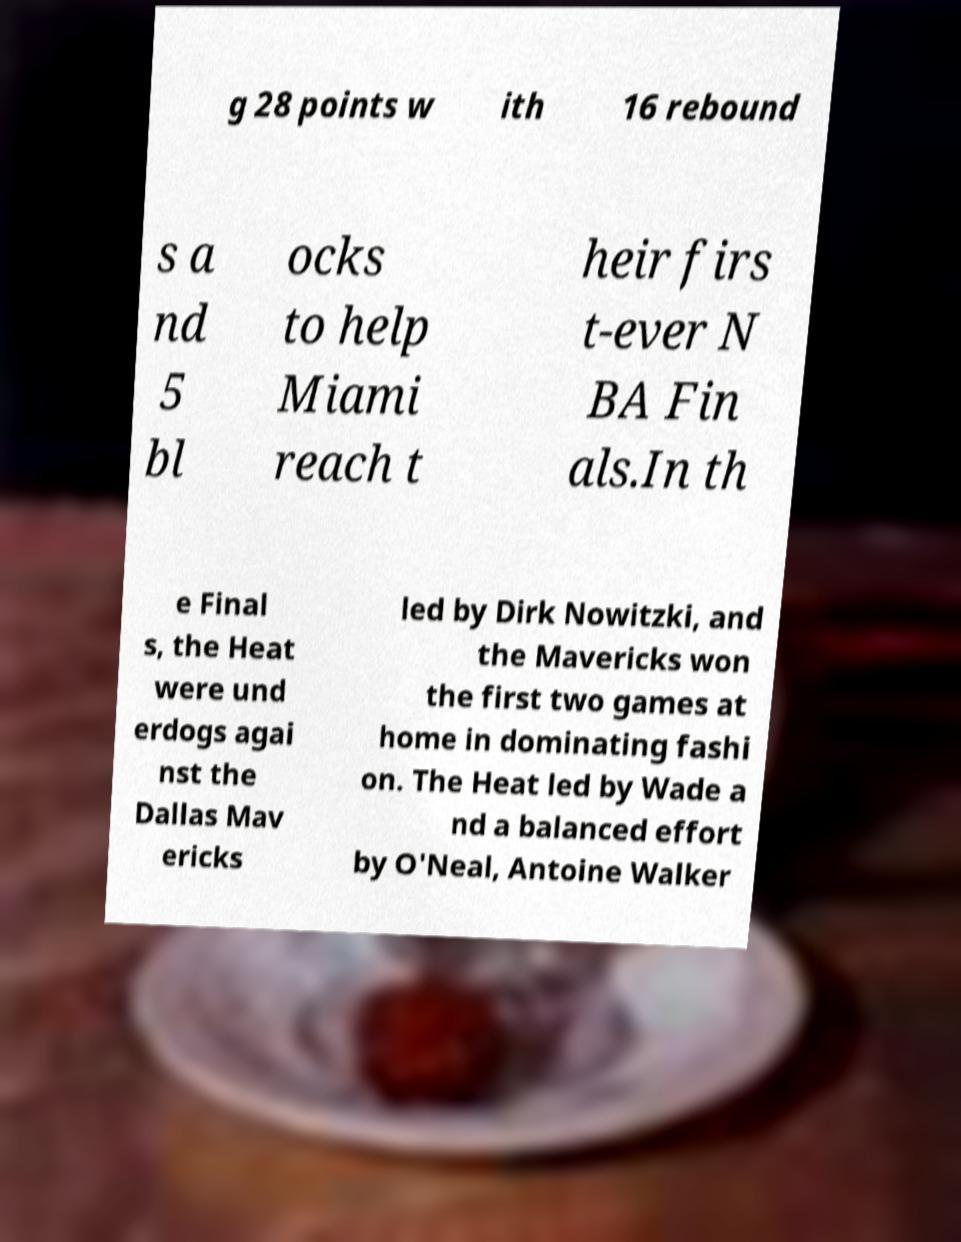I need the written content from this picture converted into text. Can you do that? g 28 points w ith 16 rebound s a nd 5 bl ocks to help Miami reach t heir firs t-ever N BA Fin als.In th e Final s, the Heat were und erdogs agai nst the Dallas Mav ericks led by Dirk Nowitzki, and the Mavericks won the first two games at home in dominating fashi on. The Heat led by Wade a nd a balanced effort by O'Neal, Antoine Walker 